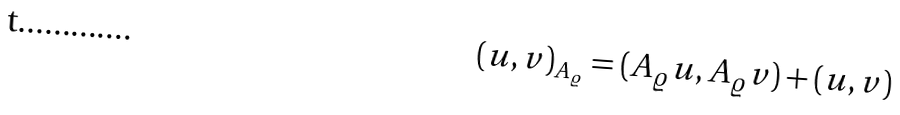Convert formula to latex. <formula><loc_0><loc_0><loc_500><loc_500>( u , v ) _ { A _ { \varrho } } = ( A _ { \varrho } u , A _ { \varrho } v ) + ( u , v )</formula> 